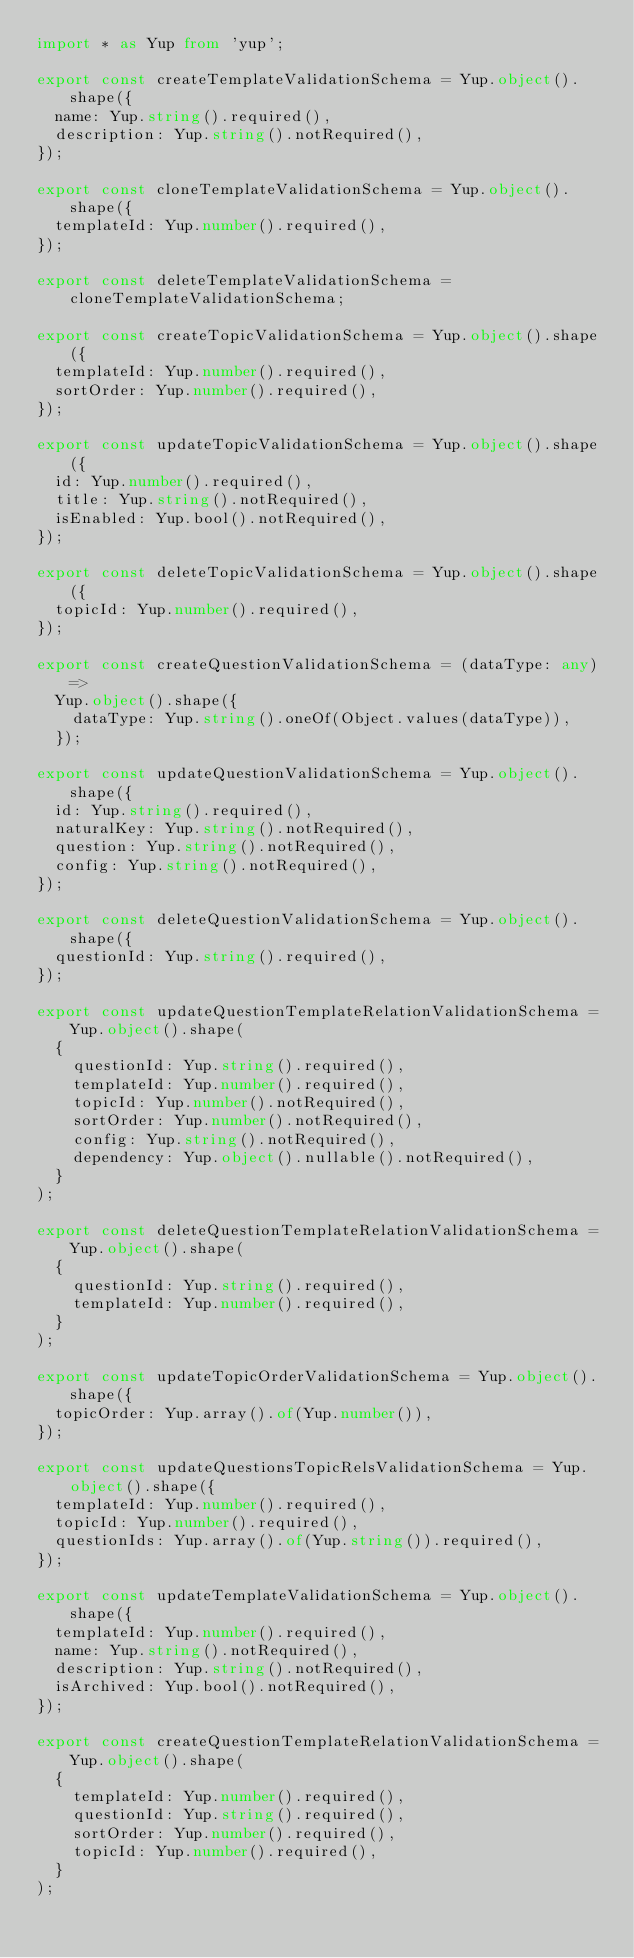<code> <loc_0><loc_0><loc_500><loc_500><_TypeScript_>import * as Yup from 'yup';

export const createTemplateValidationSchema = Yup.object().shape({
  name: Yup.string().required(),
  description: Yup.string().notRequired(),
});

export const cloneTemplateValidationSchema = Yup.object().shape({
  templateId: Yup.number().required(),
});

export const deleteTemplateValidationSchema = cloneTemplateValidationSchema;

export const createTopicValidationSchema = Yup.object().shape({
  templateId: Yup.number().required(),
  sortOrder: Yup.number().required(),
});

export const updateTopicValidationSchema = Yup.object().shape({
  id: Yup.number().required(),
  title: Yup.string().notRequired(),
  isEnabled: Yup.bool().notRequired(),
});

export const deleteTopicValidationSchema = Yup.object().shape({
  topicId: Yup.number().required(),
});

export const createQuestionValidationSchema = (dataType: any) =>
  Yup.object().shape({
    dataType: Yup.string().oneOf(Object.values(dataType)),
  });

export const updateQuestionValidationSchema = Yup.object().shape({
  id: Yup.string().required(),
  naturalKey: Yup.string().notRequired(),
  question: Yup.string().notRequired(),
  config: Yup.string().notRequired(),
});

export const deleteQuestionValidationSchema = Yup.object().shape({
  questionId: Yup.string().required(),
});

export const updateQuestionTemplateRelationValidationSchema = Yup.object().shape(
  {
    questionId: Yup.string().required(),
    templateId: Yup.number().required(),
    topicId: Yup.number().notRequired(),
    sortOrder: Yup.number().notRequired(),
    config: Yup.string().notRequired(),
    dependency: Yup.object().nullable().notRequired(),
  }
);

export const deleteQuestionTemplateRelationValidationSchema = Yup.object().shape(
  {
    questionId: Yup.string().required(),
    templateId: Yup.number().required(),
  }
);

export const updateTopicOrderValidationSchema = Yup.object().shape({
  topicOrder: Yup.array().of(Yup.number()),
});

export const updateQuestionsTopicRelsValidationSchema = Yup.object().shape({
  templateId: Yup.number().required(),
  topicId: Yup.number().required(),
  questionIds: Yup.array().of(Yup.string()).required(),
});

export const updateTemplateValidationSchema = Yup.object().shape({
  templateId: Yup.number().required(),
  name: Yup.string().notRequired(),
  description: Yup.string().notRequired(),
  isArchived: Yup.bool().notRequired(),
});

export const createQuestionTemplateRelationValidationSchema = Yup.object().shape(
  {
    templateId: Yup.number().required(),
    questionId: Yup.string().required(),
    sortOrder: Yup.number().required(),
    topicId: Yup.number().required(),
  }
);
</code> 